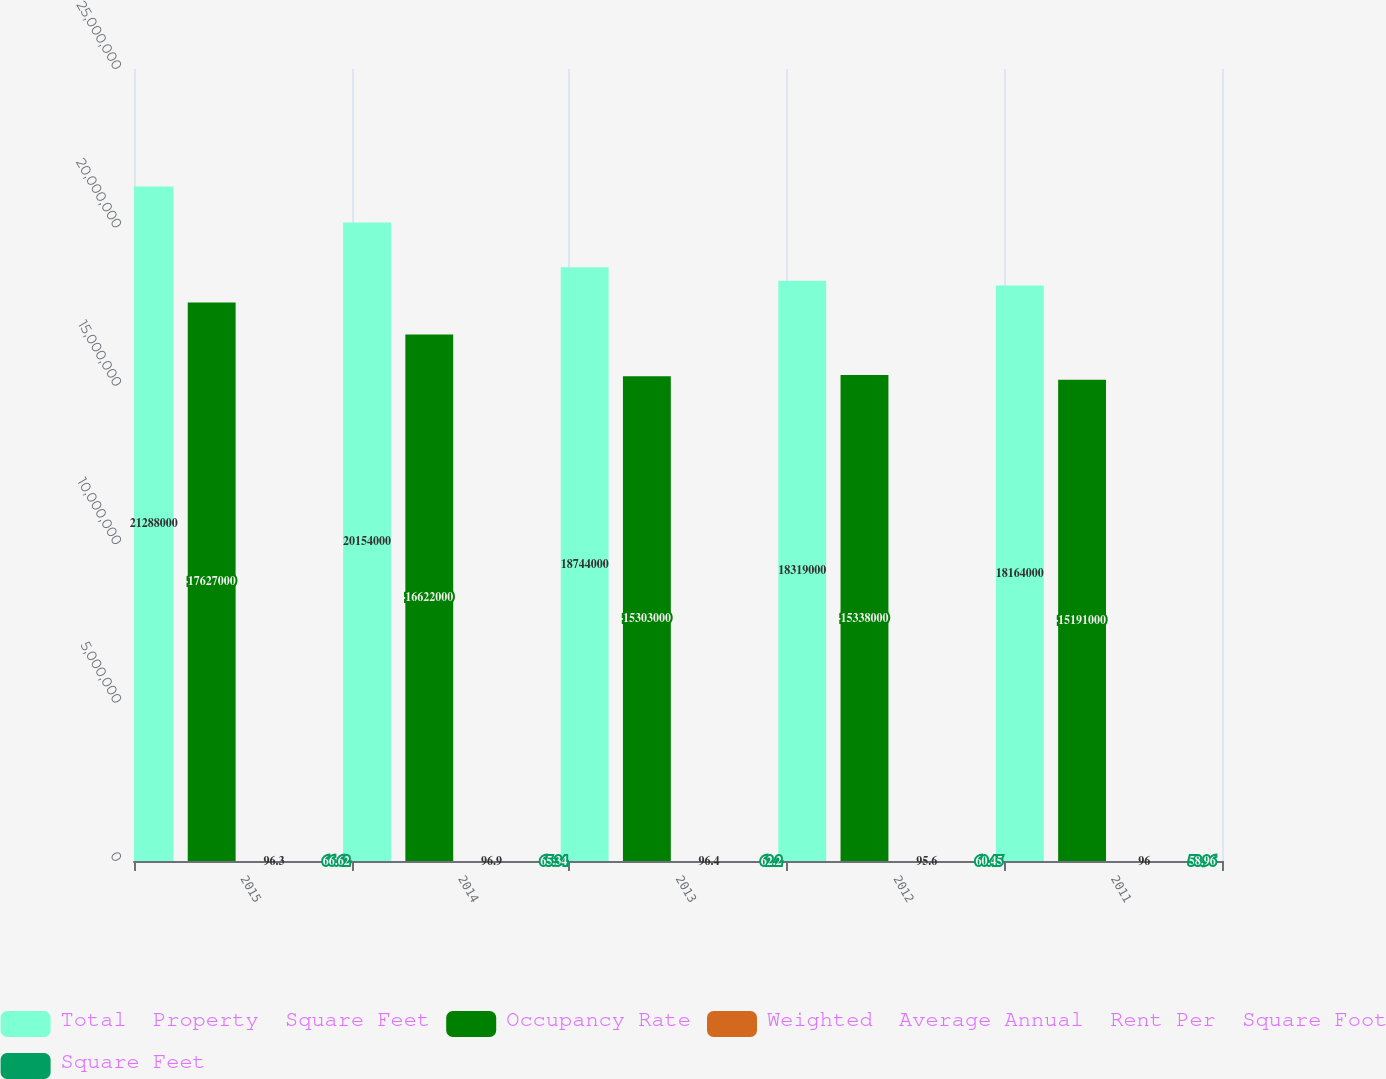Convert chart to OTSL. <chart><loc_0><loc_0><loc_500><loc_500><stacked_bar_chart><ecel><fcel>2015<fcel>2014<fcel>2013<fcel>2012<fcel>2011<nl><fcel>Total  Property  Square Feet<fcel>2.1288e+07<fcel>2.0154e+07<fcel>1.8744e+07<fcel>1.8319e+07<fcel>1.8164e+07<nl><fcel>Occupancy Rate<fcel>1.7627e+07<fcel>1.6622e+07<fcel>1.5303e+07<fcel>1.5338e+07<fcel>1.5191e+07<nl><fcel>Weighted  Average Annual  Rent Per  Square Foot<fcel>96.3<fcel>96.9<fcel>96.4<fcel>95.6<fcel>96<nl><fcel>Square Feet<fcel>66.62<fcel>65.34<fcel>62.2<fcel>60.45<fcel>58.96<nl></chart> 